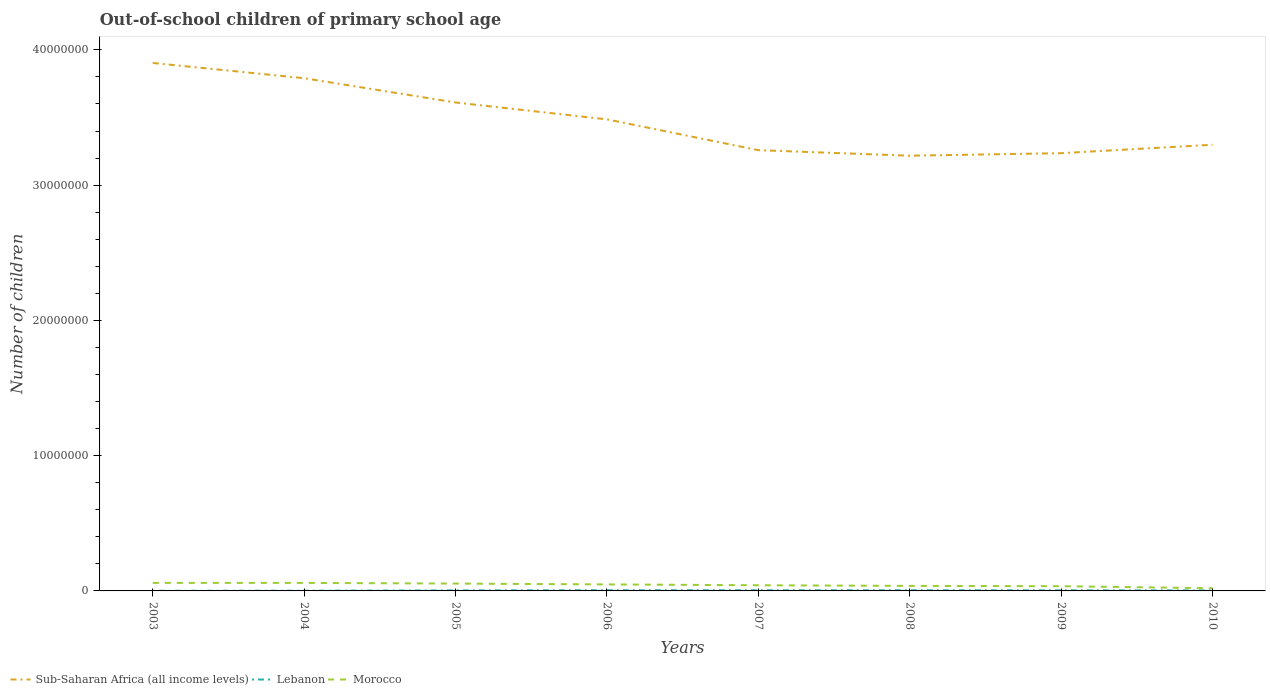How many different coloured lines are there?
Give a very brief answer. 3. Does the line corresponding to Lebanon intersect with the line corresponding to Morocco?
Provide a short and direct response. No. Across all years, what is the maximum number of out-of-school children in Sub-Saharan Africa (all income levels)?
Make the answer very short. 3.22e+07. In which year was the number of out-of-school children in Lebanon maximum?
Give a very brief answer. 2003. What is the total number of out-of-school children in Lebanon in the graph?
Make the answer very short. 1646. What is the difference between the highest and the second highest number of out-of-school children in Morocco?
Make the answer very short. 3.96e+05. Is the number of out-of-school children in Lebanon strictly greater than the number of out-of-school children in Sub-Saharan Africa (all income levels) over the years?
Your answer should be compact. Yes. How many lines are there?
Give a very brief answer. 3. How many years are there in the graph?
Offer a terse response. 8. What is the difference between two consecutive major ticks on the Y-axis?
Offer a very short reply. 1.00e+07. Are the values on the major ticks of Y-axis written in scientific E-notation?
Your answer should be compact. No. Does the graph contain any zero values?
Offer a terse response. No. Where does the legend appear in the graph?
Ensure brevity in your answer.  Bottom left. How are the legend labels stacked?
Offer a very short reply. Horizontal. What is the title of the graph?
Ensure brevity in your answer.  Out-of-school children of primary school age. Does "Costa Rica" appear as one of the legend labels in the graph?
Ensure brevity in your answer.  No. What is the label or title of the X-axis?
Offer a terse response. Years. What is the label or title of the Y-axis?
Your answer should be compact. Number of children. What is the Number of children in Sub-Saharan Africa (all income levels) in 2003?
Your answer should be very brief. 3.90e+07. What is the Number of children in Lebanon in 2003?
Your answer should be compact. 9541. What is the Number of children in Morocco in 2003?
Offer a terse response. 5.94e+05. What is the Number of children of Sub-Saharan Africa (all income levels) in 2004?
Keep it short and to the point. 3.79e+07. What is the Number of children of Lebanon in 2004?
Offer a very short reply. 1.70e+04. What is the Number of children in Morocco in 2004?
Give a very brief answer. 5.93e+05. What is the Number of children of Sub-Saharan Africa (all income levels) in 2005?
Your answer should be compact. 3.61e+07. What is the Number of children in Lebanon in 2005?
Offer a very short reply. 3.73e+04. What is the Number of children of Morocco in 2005?
Provide a succinct answer. 5.44e+05. What is the Number of children in Sub-Saharan Africa (all income levels) in 2006?
Your answer should be compact. 3.49e+07. What is the Number of children in Lebanon in 2006?
Your response must be concise. 5.22e+04. What is the Number of children in Morocco in 2006?
Ensure brevity in your answer.  4.81e+05. What is the Number of children in Sub-Saharan Africa (all income levels) in 2007?
Provide a short and direct response. 3.26e+07. What is the Number of children in Lebanon in 2007?
Provide a succinct answer. 4.99e+04. What is the Number of children in Morocco in 2007?
Give a very brief answer. 4.19e+05. What is the Number of children of Sub-Saharan Africa (all income levels) in 2008?
Provide a short and direct response. 3.22e+07. What is the Number of children of Lebanon in 2008?
Make the answer very short. 4.82e+04. What is the Number of children of Morocco in 2008?
Your answer should be compact. 3.71e+05. What is the Number of children in Sub-Saharan Africa (all income levels) in 2009?
Offer a very short reply. 3.24e+07. What is the Number of children of Lebanon in 2009?
Offer a terse response. 4.37e+04. What is the Number of children in Morocco in 2009?
Offer a very short reply. 3.49e+05. What is the Number of children of Sub-Saharan Africa (all income levels) in 2010?
Your response must be concise. 3.30e+07. What is the Number of children of Lebanon in 2010?
Keep it short and to the point. 3.49e+04. What is the Number of children in Morocco in 2010?
Your answer should be very brief. 1.98e+05. Across all years, what is the maximum Number of children in Sub-Saharan Africa (all income levels)?
Your answer should be compact. 3.90e+07. Across all years, what is the maximum Number of children of Lebanon?
Ensure brevity in your answer.  5.22e+04. Across all years, what is the maximum Number of children in Morocco?
Make the answer very short. 5.94e+05. Across all years, what is the minimum Number of children in Sub-Saharan Africa (all income levels)?
Ensure brevity in your answer.  3.22e+07. Across all years, what is the minimum Number of children of Lebanon?
Provide a succinct answer. 9541. Across all years, what is the minimum Number of children of Morocco?
Offer a terse response. 1.98e+05. What is the total Number of children in Sub-Saharan Africa (all income levels) in the graph?
Your answer should be compact. 2.78e+08. What is the total Number of children of Lebanon in the graph?
Your answer should be very brief. 2.93e+05. What is the total Number of children in Morocco in the graph?
Make the answer very short. 3.55e+06. What is the difference between the Number of children in Sub-Saharan Africa (all income levels) in 2003 and that in 2004?
Give a very brief answer. 1.13e+06. What is the difference between the Number of children of Lebanon in 2003 and that in 2004?
Ensure brevity in your answer.  -7426. What is the difference between the Number of children in Morocco in 2003 and that in 2004?
Keep it short and to the point. 761. What is the difference between the Number of children of Sub-Saharan Africa (all income levels) in 2003 and that in 2005?
Give a very brief answer. 2.92e+06. What is the difference between the Number of children in Lebanon in 2003 and that in 2005?
Provide a short and direct response. -2.78e+04. What is the difference between the Number of children in Morocco in 2003 and that in 2005?
Ensure brevity in your answer.  4.98e+04. What is the difference between the Number of children of Sub-Saharan Africa (all income levels) in 2003 and that in 2006?
Offer a very short reply. 4.17e+06. What is the difference between the Number of children of Lebanon in 2003 and that in 2006?
Keep it short and to the point. -4.26e+04. What is the difference between the Number of children in Morocco in 2003 and that in 2006?
Provide a short and direct response. 1.13e+05. What is the difference between the Number of children of Sub-Saharan Africa (all income levels) in 2003 and that in 2007?
Ensure brevity in your answer.  6.45e+06. What is the difference between the Number of children of Lebanon in 2003 and that in 2007?
Offer a very short reply. -4.03e+04. What is the difference between the Number of children in Morocco in 2003 and that in 2007?
Offer a terse response. 1.75e+05. What is the difference between the Number of children in Sub-Saharan Africa (all income levels) in 2003 and that in 2008?
Your answer should be very brief. 6.86e+06. What is the difference between the Number of children in Lebanon in 2003 and that in 2008?
Offer a very short reply. -3.87e+04. What is the difference between the Number of children of Morocco in 2003 and that in 2008?
Provide a short and direct response. 2.22e+05. What is the difference between the Number of children in Sub-Saharan Africa (all income levels) in 2003 and that in 2009?
Your response must be concise. 6.67e+06. What is the difference between the Number of children in Lebanon in 2003 and that in 2009?
Give a very brief answer. -3.42e+04. What is the difference between the Number of children in Morocco in 2003 and that in 2009?
Provide a succinct answer. 2.44e+05. What is the difference between the Number of children in Sub-Saharan Africa (all income levels) in 2003 and that in 2010?
Offer a very short reply. 6.05e+06. What is the difference between the Number of children in Lebanon in 2003 and that in 2010?
Provide a succinct answer. -2.54e+04. What is the difference between the Number of children of Morocco in 2003 and that in 2010?
Ensure brevity in your answer.  3.96e+05. What is the difference between the Number of children in Sub-Saharan Africa (all income levels) in 2004 and that in 2005?
Provide a succinct answer. 1.80e+06. What is the difference between the Number of children in Lebanon in 2004 and that in 2005?
Make the answer very short. -2.03e+04. What is the difference between the Number of children in Morocco in 2004 and that in 2005?
Offer a very short reply. 4.90e+04. What is the difference between the Number of children of Sub-Saharan Africa (all income levels) in 2004 and that in 2006?
Keep it short and to the point. 3.04e+06. What is the difference between the Number of children of Lebanon in 2004 and that in 2006?
Your answer should be compact. -3.52e+04. What is the difference between the Number of children of Morocco in 2004 and that in 2006?
Give a very brief answer. 1.12e+05. What is the difference between the Number of children of Sub-Saharan Africa (all income levels) in 2004 and that in 2007?
Give a very brief answer. 5.32e+06. What is the difference between the Number of children in Lebanon in 2004 and that in 2007?
Offer a very short reply. -3.29e+04. What is the difference between the Number of children of Morocco in 2004 and that in 2007?
Your response must be concise. 1.74e+05. What is the difference between the Number of children in Sub-Saharan Africa (all income levels) in 2004 and that in 2008?
Offer a very short reply. 5.73e+06. What is the difference between the Number of children of Lebanon in 2004 and that in 2008?
Your answer should be very brief. -3.12e+04. What is the difference between the Number of children of Morocco in 2004 and that in 2008?
Offer a very short reply. 2.21e+05. What is the difference between the Number of children in Sub-Saharan Africa (all income levels) in 2004 and that in 2009?
Offer a terse response. 5.54e+06. What is the difference between the Number of children in Lebanon in 2004 and that in 2009?
Keep it short and to the point. -2.68e+04. What is the difference between the Number of children in Morocco in 2004 and that in 2009?
Provide a succinct answer. 2.44e+05. What is the difference between the Number of children in Sub-Saharan Africa (all income levels) in 2004 and that in 2010?
Provide a succinct answer. 4.92e+06. What is the difference between the Number of children in Lebanon in 2004 and that in 2010?
Keep it short and to the point. -1.80e+04. What is the difference between the Number of children in Morocco in 2004 and that in 2010?
Provide a short and direct response. 3.95e+05. What is the difference between the Number of children of Sub-Saharan Africa (all income levels) in 2005 and that in 2006?
Ensure brevity in your answer.  1.25e+06. What is the difference between the Number of children of Lebanon in 2005 and that in 2006?
Provide a succinct answer. -1.49e+04. What is the difference between the Number of children of Morocco in 2005 and that in 2006?
Keep it short and to the point. 6.29e+04. What is the difference between the Number of children in Sub-Saharan Africa (all income levels) in 2005 and that in 2007?
Make the answer very short. 3.52e+06. What is the difference between the Number of children of Lebanon in 2005 and that in 2007?
Your answer should be compact. -1.26e+04. What is the difference between the Number of children in Morocco in 2005 and that in 2007?
Give a very brief answer. 1.25e+05. What is the difference between the Number of children in Sub-Saharan Africa (all income levels) in 2005 and that in 2008?
Your response must be concise. 3.93e+06. What is the difference between the Number of children of Lebanon in 2005 and that in 2008?
Your response must be concise. -1.09e+04. What is the difference between the Number of children of Morocco in 2005 and that in 2008?
Keep it short and to the point. 1.72e+05. What is the difference between the Number of children in Sub-Saharan Africa (all income levels) in 2005 and that in 2009?
Give a very brief answer. 3.75e+06. What is the difference between the Number of children of Lebanon in 2005 and that in 2009?
Provide a short and direct response. -6422. What is the difference between the Number of children of Morocco in 2005 and that in 2009?
Keep it short and to the point. 1.95e+05. What is the difference between the Number of children of Sub-Saharan Africa (all income levels) in 2005 and that in 2010?
Your response must be concise. 3.13e+06. What is the difference between the Number of children of Lebanon in 2005 and that in 2010?
Your answer should be compact. 2365. What is the difference between the Number of children of Morocco in 2005 and that in 2010?
Your answer should be compact. 3.46e+05. What is the difference between the Number of children of Sub-Saharan Africa (all income levels) in 2006 and that in 2007?
Your answer should be very brief. 2.28e+06. What is the difference between the Number of children in Lebanon in 2006 and that in 2007?
Provide a short and direct response. 2324. What is the difference between the Number of children of Morocco in 2006 and that in 2007?
Your answer should be very brief. 6.23e+04. What is the difference between the Number of children in Sub-Saharan Africa (all income levels) in 2006 and that in 2008?
Offer a terse response. 2.69e+06. What is the difference between the Number of children of Lebanon in 2006 and that in 2008?
Ensure brevity in your answer.  3970. What is the difference between the Number of children of Morocco in 2006 and that in 2008?
Make the answer very short. 1.10e+05. What is the difference between the Number of children in Sub-Saharan Africa (all income levels) in 2006 and that in 2009?
Your response must be concise. 2.50e+06. What is the difference between the Number of children of Lebanon in 2006 and that in 2009?
Your response must be concise. 8468. What is the difference between the Number of children in Morocco in 2006 and that in 2009?
Your answer should be compact. 1.32e+05. What is the difference between the Number of children of Sub-Saharan Africa (all income levels) in 2006 and that in 2010?
Your answer should be compact. 1.88e+06. What is the difference between the Number of children in Lebanon in 2006 and that in 2010?
Your answer should be very brief. 1.73e+04. What is the difference between the Number of children of Morocco in 2006 and that in 2010?
Your response must be concise. 2.83e+05. What is the difference between the Number of children in Sub-Saharan Africa (all income levels) in 2007 and that in 2008?
Your answer should be very brief. 4.10e+05. What is the difference between the Number of children in Lebanon in 2007 and that in 2008?
Keep it short and to the point. 1646. What is the difference between the Number of children in Morocco in 2007 and that in 2008?
Offer a terse response. 4.72e+04. What is the difference between the Number of children in Sub-Saharan Africa (all income levels) in 2007 and that in 2009?
Give a very brief answer. 2.23e+05. What is the difference between the Number of children in Lebanon in 2007 and that in 2009?
Offer a terse response. 6144. What is the difference between the Number of children of Morocco in 2007 and that in 2009?
Offer a very short reply. 6.94e+04. What is the difference between the Number of children of Sub-Saharan Africa (all income levels) in 2007 and that in 2010?
Make the answer very short. -3.99e+05. What is the difference between the Number of children in Lebanon in 2007 and that in 2010?
Your answer should be compact. 1.49e+04. What is the difference between the Number of children of Morocco in 2007 and that in 2010?
Your answer should be very brief. 2.21e+05. What is the difference between the Number of children in Sub-Saharan Africa (all income levels) in 2008 and that in 2009?
Make the answer very short. -1.87e+05. What is the difference between the Number of children of Lebanon in 2008 and that in 2009?
Your answer should be compact. 4498. What is the difference between the Number of children in Morocco in 2008 and that in 2009?
Your response must be concise. 2.22e+04. What is the difference between the Number of children of Sub-Saharan Africa (all income levels) in 2008 and that in 2010?
Your answer should be very brief. -8.09e+05. What is the difference between the Number of children of Lebanon in 2008 and that in 2010?
Your answer should be very brief. 1.33e+04. What is the difference between the Number of children of Morocco in 2008 and that in 2010?
Your answer should be compact. 1.74e+05. What is the difference between the Number of children of Sub-Saharan Africa (all income levels) in 2009 and that in 2010?
Provide a succinct answer. -6.22e+05. What is the difference between the Number of children of Lebanon in 2009 and that in 2010?
Provide a short and direct response. 8787. What is the difference between the Number of children in Morocco in 2009 and that in 2010?
Make the answer very short. 1.52e+05. What is the difference between the Number of children in Sub-Saharan Africa (all income levels) in 2003 and the Number of children in Lebanon in 2004?
Give a very brief answer. 3.90e+07. What is the difference between the Number of children of Sub-Saharan Africa (all income levels) in 2003 and the Number of children of Morocco in 2004?
Your answer should be very brief. 3.84e+07. What is the difference between the Number of children in Lebanon in 2003 and the Number of children in Morocco in 2004?
Make the answer very short. -5.83e+05. What is the difference between the Number of children in Sub-Saharan Africa (all income levels) in 2003 and the Number of children in Lebanon in 2005?
Offer a very short reply. 3.90e+07. What is the difference between the Number of children in Sub-Saharan Africa (all income levels) in 2003 and the Number of children in Morocco in 2005?
Offer a very short reply. 3.85e+07. What is the difference between the Number of children in Lebanon in 2003 and the Number of children in Morocco in 2005?
Your response must be concise. -5.34e+05. What is the difference between the Number of children in Sub-Saharan Africa (all income levels) in 2003 and the Number of children in Lebanon in 2006?
Provide a succinct answer. 3.90e+07. What is the difference between the Number of children of Sub-Saharan Africa (all income levels) in 2003 and the Number of children of Morocco in 2006?
Offer a very short reply. 3.86e+07. What is the difference between the Number of children in Lebanon in 2003 and the Number of children in Morocco in 2006?
Provide a succinct answer. -4.71e+05. What is the difference between the Number of children of Sub-Saharan Africa (all income levels) in 2003 and the Number of children of Lebanon in 2007?
Ensure brevity in your answer.  3.90e+07. What is the difference between the Number of children of Sub-Saharan Africa (all income levels) in 2003 and the Number of children of Morocco in 2007?
Make the answer very short. 3.86e+07. What is the difference between the Number of children in Lebanon in 2003 and the Number of children in Morocco in 2007?
Provide a succinct answer. -4.09e+05. What is the difference between the Number of children in Sub-Saharan Africa (all income levels) in 2003 and the Number of children in Lebanon in 2008?
Your answer should be very brief. 3.90e+07. What is the difference between the Number of children in Sub-Saharan Africa (all income levels) in 2003 and the Number of children in Morocco in 2008?
Keep it short and to the point. 3.87e+07. What is the difference between the Number of children in Lebanon in 2003 and the Number of children in Morocco in 2008?
Your answer should be very brief. -3.62e+05. What is the difference between the Number of children in Sub-Saharan Africa (all income levels) in 2003 and the Number of children in Lebanon in 2009?
Offer a terse response. 3.90e+07. What is the difference between the Number of children of Sub-Saharan Africa (all income levels) in 2003 and the Number of children of Morocco in 2009?
Offer a very short reply. 3.87e+07. What is the difference between the Number of children in Lebanon in 2003 and the Number of children in Morocco in 2009?
Give a very brief answer. -3.40e+05. What is the difference between the Number of children in Sub-Saharan Africa (all income levels) in 2003 and the Number of children in Lebanon in 2010?
Your answer should be very brief. 3.90e+07. What is the difference between the Number of children of Sub-Saharan Africa (all income levels) in 2003 and the Number of children of Morocco in 2010?
Offer a very short reply. 3.88e+07. What is the difference between the Number of children in Lebanon in 2003 and the Number of children in Morocco in 2010?
Keep it short and to the point. -1.88e+05. What is the difference between the Number of children in Sub-Saharan Africa (all income levels) in 2004 and the Number of children in Lebanon in 2005?
Your answer should be compact. 3.79e+07. What is the difference between the Number of children of Sub-Saharan Africa (all income levels) in 2004 and the Number of children of Morocco in 2005?
Offer a terse response. 3.74e+07. What is the difference between the Number of children of Lebanon in 2004 and the Number of children of Morocco in 2005?
Give a very brief answer. -5.27e+05. What is the difference between the Number of children in Sub-Saharan Africa (all income levels) in 2004 and the Number of children in Lebanon in 2006?
Provide a succinct answer. 3.79e+07. What is the difference between the Number of children in Sub-Saharan Africa (all income levels) in 2004 and the Number of children in Morocco in 2006?
Your answer should be compact. 3.74e+07. What is the difference between the Number of children in Lebanon in 2004 and the Number of children in Morocco in 2006?
Your answer should be compact. -4.64e+05. What is the difference between the Number of children in Sub-Saharan Africa (all income levels) in 2004 and the Number of children in Lebanon in 2007?
Provide a short and direct response. 3.79e+07. What is the difference between the Number of children in Sub-Saharan Africa (all income levels) in 2004 and the Number of children in Morocco in 2007?
Provide a short and direct response. 3.75e+07. What is the difference between the Number of children of Lebanon in 2004 and the Number of children of Morocco in 2007?
Give a very brief answer. -4.02e+05. What is the difference between the Number of children of Sub-Saharan Africa (all income levels) in 2004 and the Number of children of Lebanon in 2008?
Your answer should be very brief. 3.79e+07. What is the difference between the Number of children of Sub-Saharan Africa (all income levels) in 2004 and the Number of children of Morocco in 2008?
Give a very brief answer. 3.75e+07. What is the difference between the Number of children in Lebanon in 2004 and the Number of children in Morocco in 2008?
Provide a succinct answer. -3.54e+05. What is the difference between the Number of children of Sub-Saharan Africa (all income levels) in 2004 and the Number of children of Lebanon in 2009?
Provide a short and direct response. 3.79e+07. What is the difference between the Number of children in Sub-Saharan Africa (all income levels) in 2004 and the Number of children in Morocco in 2009?
Offer a terse response. 3.76e+07. What is the difference between the Number of children in Lebanon in 2004 and the Number of children in Morocco in 2009?
Keep it short and to the point. -3.32e+05. What is the difference between the Number of children in Sub-Saharan Africa (all income levels) in 2004 and the Number of children in Lebanon in 2010?
Ensure brevity in your answer.  3.79e+07. What is the difference between the Number of children of Sub-Saharan Africa (all income levels) in 2004 and the Number of children of Morocco in 2010?
Offer a very short reply. 3.77e+07. What is the difference between the Number of children in Lebanon in 2004 and the Number of children in Morocco in 2010?
Provide a succinct answer. -1.81e+05. What is the difference between the Number of children of Sub-Saharan Africa (all income levels) in 2005 and the Number of children of Lebanon in 2006?
Your answer should be compact. 3.61e+07. What is the difference between the Number of children in Sub-Saharan Africa (all income levels) in 2005 and the Number of children in Morocco in 2006?
Offer a very short reply. 3.56e+07. What is the difference between the Number of children of Lebanon in 2005 and the Number of children of Morocco in 2006?
Your response must be concise. -4.44e+05. What is the difference between the Number of children in Sub-Saharan Africa (all income levels) in 2005 and the Number of children in Lebanon in 2007?
Ensure brevity in your answer.  3.61e+07. What is the difference between the Number of children of Sub-Saharan Africa (all income levels) in 2005 and the Number of children of Morocco in 2007?
Provide a succinct answer. 3.57e+07. What is the difference between the Number of children of Lebanon in 2005 and the Number of children of Morocco in 2007?
Your response must be concise. -3.81e+05. What is the difference between the Number of children of Sub-Saharan Africa (all income levels) in 2005 and the Number of children of Lebanon in 2008?
Provide a short and direct response. 3.61e+07. What is the difference between the Number of children in Sub-Saharan Africa (all income levels) in 2005 and the Number of children in Morocco in 2008?
Provide a short and direct response. 3.57e+07. What is the difference between the Number of children of Lebanon in 2005 and the Number of children of Morocco in 2008?
Offer a terse response. -3.34e+05. What is the difference between the Number of children in Sub-Saharan Africa (all income levels) in 2005 and the Number of children in Lebanon in 2009?
Make the answer very short. 3.61e+07. What is the difference between the Number of children of Sub-Saharan Africa (all income levels) in 2005 and the Number of children of Morocco in 2009?
Make the answer very short. 3.58e+07. What is the difference between the Number of children in Lebanon in 2005 and the Number of children in Morocco in 2009?
Offer a very short reply. -3.12e+05. What is the difference between the Number of children in Sub-Saharan Africa (all income levels) in 2005 and the Number of children in Lebanon in 2010?
Give a very brief answer. 3.61e+07. What is the difference between the Number of children in Sub-Saharan Africa (all income levels) in 2005 and the Number of children in Morocco in 2010?
Offer a terse response. 3.59e+07. What is the difference between the Number of children of Lebanon in 2005 and the Number of children of Morocco in 2010?
Give a very brief answer. -1.60e+05. What is the difference between the Number of children in Sub-Saharan Africa (all income levels) in 2006 and the Number of children in Lebanon in 2007?
Keep it short and to the point. 3.48e+07. What is the difference between the Number of children of Sub-Saharan Africa (all income levels) in 2006 and the Number of children of Morocco in 2007?
Make the answer very short. 3.44e+07. What is the difference between the Number of children of Lebanon in 2006 and the Number of children of Morocco in 2007?
Your answer should be very brief. -3.66e+05. What is the difference between the Number of children of Sub-Saharan Africa (all income levels) in 2006 and the Number of children of Lebanon in 2008?
Offer a terse response. 3.48e+07. What is the difference between the Number of children of Sub-Saharan Africa (all income levels) in 2006 and the Number of children of Morocco in 2008?
Ensure brevity in your answer.  3.45e+07. What is the difference between the Number of children in Lebanon in 2006 and the Number of children in Morocco in 2008?
Offer a terse response. -3.19e+05. What is the difference between the Number of children of Sub-Saharan Africa (all income levels) in 2006 and the Number of children of Lebanon in 2009?
Offer a terse response. 3.48e+07. What is the difference between the Number of children of Sub-Saharan Africa (all income levels) in 2006 and the Number of children of Morocco in 2009?
Give a very brief answer. 3.45e+07. What is the difference between the Number of children of Lebanon in 2006 and the Number of children of Morocco in 2009?
Ensure brevity in your answer.  -2.97e+05. What is the difference between the Number of children in Sub-Saharan Africa (all income levels) in 2006 and the Number of children in Lebanon in 2010?
Your answer should be compact. 3.48e+07. What is the difference between the Number of children of Sub-Saharan Africa (all income levels) in 2006 and the Number of children of Morocco in 2010?
Ensure brevity in your answer.  3.47e+07. What is the difference between the Number of children in Lebanon in 2006 and the Number of children in Morocco in 2010?
Offer a terse response. -1.45e+05. What is the difference between the Number of children in Sub-Saharan Africa (all income levels) in 2007 and the Number of children in Lebanon in 2008?
Keep it short and to the point. 3.25e+07. What is the difference between the Number of children in Sub-Saharan Africa (all income levels) in 2007 and the Number of children in Morocco in 2008?
Offer a terse response. 3.22e+07. What is the difference between the Number of children of Lebanon in 2007 and the Number of children of Morocco in 2008?
Your answer should be compact. -3.22e+05. What is the difference between the Number of children in Sub-Saharan Africa (all income levels) in 2007 and the Number of children in Lebanon in 2009?
Your response must be concise. 3.25e+07. What is the difference between the Number of children in Sub-Saharan Africa (all income levels) in 2007 and the Number of children in Morocco in 2009?
Provide a short and direct response. 3.22e+07. What is the difference between the Number of children of Lebanon in 2007 and the Number of children of Morocco in 2009?
Provide a succinct answer. -2.99e+05. What is the difference between the Number of children of Sub-Saharan Africa (all income levels) in 2007 and the Number of children of Lebanon in 2010?
Keep it short and to the point. 3.26e+07. What is the difference between the Number of children of Sub-Saharan Africa (all income levels) in 2007 and the Number of children of Morocco in 2010?
Provide a short and direct response. 3.24e+07. What is the difference between the Number of children of Lebanon in 2007 and the Number of children of Morocco in 2010?
Keep it short and to the point. -1.48e+05. What is the difference between the Number of children of Sub-Saharan Africa (all income levels) in 2008 and the Number of children of Lebanon in 2009?
Offer a very short reply. 3.21e+07. What is the difference between the Number of children of Sub-Saharan Africa (all income levels) in 2008 and the Number of children of Morocco in 2009?
Make the answer very short. 3.18e+07. What is the difference between the Number of children in Lebanon in 2008 and the Number of children in Morocco in 2009?
Give a very brief answer. -3.01e+05. What is the difference between the Number of children of Sub-Saharan Africa (all income levels) in 2008 and the Number of children of Lebanon in 2010?
Offer a terse response. 3.21e+07. What is the difference between the Number of children of Sub-Saharan Africa (all income levels) in 2008 and the Number of children of Morocco in 2010?
Your answer should be compact. 3.20e+07. What is the difference between the Number of children in Lebanon in 2008 and the Number of children in Morocco in 2010?
Offer a very short reply. -1.49e+05. What is the difference between the Number of children in Sub-Saharan Africa (all income levels) in 2009 and the Number of children in Lebanon in 2010?
Your answer should be very brief. 3.23e+07. What is the difference between the Number of children in Sub-Saharan Africa (all income levels) in 2009 and the Number of children in Morocco in 2010?
Your response must be concise. 3.22e+07. What is the difference between the Number of children in Lebanon in 2009 and the Number of children in Morocco in 2010?
Keep it short and to the point. -1.54e+05. What is the average Number of children in Sub-Saharan Africa (all income levels) per year?
Provide a short and direct response. 3.48e+07. What is the average Number of children in Lebanon per year?
Make the answer very short. 3.66e+04. What is the average Number of children in Morocco per year?
Offer a very short reply. 4.44e+05. In the year 2003, what is the difference between the Number of children in Sub-Saharan Africa (all income levels) and Number of children in Lebanon?
Make the answer very short. 3.90e+07. In the year 2003, what is the difference between the Number of children in Sub-Saharan Africa (all income levels) and Number of children in Morocco?
Give a very brief answer. 3.84e+07. In the year 2003, what is the difference between the Number of children in Lebanon and Number of children in Morocco?
Provide a short and direct response. -5.84e+05. In the year 2004, what is the difference between the Number of children in Sub-Saharan Africa (all income levels) and Number of children in Lebanon?
Your answer should be compact. 3.79e+07. In the year 2004, what is the difference between the Number of children in Sub-Saharan Africa (all income levels) and Number of children in Morocco?
Provide a short and direct response. 3.73e+07. In the year 2004, what is the difference between the Number of children in Lebanon and Number of children in Morocco?
Give a very brief answer. -5.76e+05. In the year 2005, what is the difference between the Number of children of Sub-Saharan Africa (all income levels) and Number of children of Lebanon?
Offer a very short reply. 3.61e+07. In the year 2005, what is the difference between the Number of children in Sub-Saharan Africa (all income levels) and Number of children in Morocco?
Provide a succinct answer. 3.56e+07. In the year 2005, what is the difference between the Number of children of Lebanon and Number of children of Morocco?
Make the answer very short. -5.07e+05. In the year 2006, what is the difference between the Number of children in Sub-Saharan Africa (all income levels) and Number of children in Lebanon?
Ensure brevity in your answer.  3.48e+07. In the year 2006, what is the difference between the Number of children of Sub-Saharan Africa (all income levels) and Number of children of Morocco?
Give a very brief answer. 3.44e+07. In the year 2006, what is the difference between the Number of children of Lebanon and Number of children of Morocco?
Provide a succinct answer. -4.29e+05. In the year 2007, what is the difference between the Number of children of Sub-Saharan Africa (all income levels) and Number of children of Lebanon?
Ensure brevity in your answer.  3.25e+07. In the year 2007, what is the difference between the Number of children of Sub-Saharan Africa (all income levels) and Number of children of Morocco?
Ensure brevity in your answer.  3.22e+07. In the year 2007, what is the difference between the Number of children in Lebanon and Number of children in Morocco?
Offer a terse response. -3.69e+05. In the year 2008, what is the difference between the Number of children in Sub-Saharan Africa (all income levels) and Number of children in Lebanon?
Offer a terse response. 3.21e+07. In the year 2008, what is the difference between the Number of children of Sub-Saharan Africa (all income levels) and Number of children of Morocco?
Make the answer very short. 3.18e+07. In the year 2008, what is the difference between the Number of children of Lebanon and Number of children of Morocco?
Your answer should be compact. -3.23e+05. In the year 2009, what is the difference between the Number of children in Sub-Saharan Africa (all income levels) and Number of children in Lebanon?
Your response must be concise. 3.23e+07. In the year 2009, what is the difference between the Number of children of Sub-Saharan Africa (all income levels) and Number of children of Morocco?
Your answer should be compact. 3.20e+07. In the year 2009, what is the difference between the Number of children of Lebanon and Number of children of Morocco?
Make the answer very short. -3.06e+05. In the year 2010, what is the difference between the Number of children of Sub-Saharan Africa (all income levels) and Number of children of Lebanon?
Offer a very short reply. 3.29e+07. In the year 2010, what is the difference between the Number of children of Sub-Saharan Africa (all income levels) and Number of children of Morocco?
Your answer should be very brief. 3.28e+07. In the year 2010, what is the difference between the Number of children in Lebanon and Number of children in Morocco?
Your answer should be very brief. -1.63e+05. What is the ratio of the Number of children of Sub-Saharan Africa (all income levels) in 2003 to that in 2004?
Your answer should be compact. 1.03. What is the ratio of the Number of children of Lebanon in 2003 to that in 2004?
Provide a succinct answer. 0.56. What is the ratio of the Number of children in Sub-Saharan Africa (all income levels) in 2003 to that in 2005?
Offer a terse response. 1.08. What is the ratio of the Number of children in Lebanon in 2003 to that in 2005?
Provide a short and direct response. 0.26. What is the ratio of the Number of children of Morocco in 2003 to that in 2005?
Offer a very short reply. 1.09. What is the ratio of the Number of children in Sub-Saharan Africa (all income levels) in 2003 to that in 2006?
Ensure brevity in your answer.  1.12. What is the ratio of the Number of children of Lebanon in 2003 to that in 2006?
Your response must be concise. 0.18. What is the ratio of the Number of children of Morocco in 2003 to that in 2006?
Ensure brevity in your answer.  1.23. What is the ratio of the Number of children of Sub-Saharan Africa (all income levels) in 2003 to that in 2007?
Provide a succinct answer. 1.2. What is the ratio of the Number of children of Lebanon in 2003 to that in 2007?
Your response must be concise. 0.19. What is the ratio of the Number of children of Morocco in 2003 to that in 2007?
Provide a short and direct response. 1.42. What is the ratio of the Number of children in Sub-Saharan Africa (all income levels) in 2003 to that in 2008?
Keep it short and to the point. 1.21. What is the ratio of the Number of children in Lebanon in 2003 to that in 2008?
Provide a succinct answer. 0.2. What is the ratio of the Number of children of Morocco in 2003 to that in 2008?
Provide a succinct answer. 1.6. What is the ratio of the Number of children of Sub-Saharan Africa (all income levels) in 2003 to that in 2009?
Ensure brevity in your answer.  1.21. What is the ratio of the Number of children of Lebanon in 2003 to that in 2009?
Make the answer very short. 0.22. What is the ratio of the Number of children of Morocco in 2003 to that in 2009?
Give a very brief answer. 1.7. What is the ratio of the Number of children in Sub-Saharan Africa (all income levels) in 2003 to that in 2010?
Your response must be concise. 1.18. What is the ratio of the Number of children of Lebanon in 2003 to that in 2010?
Keep it short and to the point. 0.27. What is the ratio of the Number of children in Morocco in 2003 to that in 2010?
Your answer should be very brief. 3. What is the ratio of the Number of children in Sub-Saharan Africa (all income levels) in 2004 to that in 2005?
Your answer should be very brief. 1.05. What is the ratio of the Number of children of Lebanon in 2004 to that in 2005?
Provide a short and direct response. 0.45. What is the ratio of the Number of children of Morocco in 2004 to that in 2005?
Your response must be concise. 1.09. What is the ratio of the Number of children in Sub-Saharan Africa (all income levels) in 2004 to that in 2006?
Your response must be concise. 1.09. What is the ratio of the Number of children in Lebanon in 2004 to that in 2006?
Keep it short and to the point. 0.33. What is the ratio of the Number of children of Morocco in 2004 to that in 2006?
Make the answer very short. 1.23. What is the ratio of the Number of children in Sub-Saharan Africa (all income levels) in 2004 to that in 2007?
Your response must be concise. 1.16. What is the ratio of the Number of children of Lebanon in 2004 to that in 2007?
Provide a short and direct response. 0.34. What is the ratio of the Number of children in Morocco in 2004 to that in 2007?
Provide a succinct answer. 1.42. What is the ratio of the Number of children in Sub-Saharan Africa (all income levels) in 2004 to that in 2008?
Your response must be concise. 1.18. What is the ratio of the Number of children of Lebanon in 2004 to that in 2008?
Make the answer very short. 0.35. What is the ratio of the Number of children in Morocco in 2004 to that in 2008?
Provide a succinct answer. 1.6. What is the ratio of the Number of children in Sub-Saharan Africa (all income levels) in 2004 to that in 2009?
Offer a terse response. 1.17. What is the ratio of the Number of children of Lebanon in 2004 to that in 2009?
Keep it short and to the point. 0.39. What is the ratio of the Number of children in Morocco in 2004 to that in 2009?
Your response must be concise. 1.7. What is the ratio of the Number of children in Sub-Saharan Africa (all income levels) in 2004 to that in 2010?
Make the answer very short. 1.15. What is the ratio of the Number of children of Lebanon in 2004 to that in 2010?
Your response must be concise. 0.49. What is the ratio of the Number of children of Morocco in 2004 to that in 2010?
Ensure brevity in your answer.  3. What is the ratio of the Number of children in Sub-Saharan Africa (all income levels) in 2005 to that in 2006?
Make the answer very short. 1.04. What is the ratio of the Number of children in Lebanon in 2005 to that in 2006?
Your answer should be very brief. 0.71. What is the ratio of the Number of children of Morocco in 2005 to that in 2006?
Give a very brief answer. 1.13. What is the ratio of the Number of children of Sub-Saharan Africa (all income levels) in 2005 to that in 2007?
Keep it short and to the point. 1.11. What is the ratio of the Number of children in Lebanon in 2005 to that in 2007?
Your answer should be compact. 0.75. What is the ratio of the Number of children of Morocco in 2005 to that in 2007?
Offer a terse response. 1.3. What is the ratio of the Number of children of Sub-Saharan Africa (all income levels) in 2005 to that in 2008?
Provide a succinct answer. 1.12. What is the ratio of the Number of children in Lebanon in 2005 to that in 2008?
Give a very brief answer. 0.77. What is the ratio of the Number of children in Morocco in 2005 to that in 2008?
Offer a terse response. 1.46. What is the ratio of the Number of children of Sub-Saharan Africa (all income levels) in 2005 to that in 2009?
Your answer should be compact. 1.12. What is the ratio of the Number of children in Lebanon in 2005 to that in 2009?
Provide a short and direct response. 0.85. What is the ratio of the Number of children in Morocco in 2005 to that in 2009?
Provide a succinct answer. 1.56. What is the ratio of the Number of children of Sub-Saharan Africa (all income levels) in 2005 to that in 2010?
Your answer should be compact. 1.09. What is the ratio of the Number of children of Lebanon in 2005 to that in 2010?
Your response must be concise. 1.07. What is the ratio of the Number of children in Morocco in 2005 to that in 2010?
Your response must be concise. 2.75. What is the ratio of the Number of children in Sub-Saharan Africa (all income levels) in 2006 to that in 2007?
Offer a very short reply. 1.07. What is the ratio of the Number of children of Lebanon in 2006 to that in 2007?
Provide a succinct answer. 1.05. What is the ratio of the Number of children in Morocco in 2006 to that in 2007?
Offer a terse response. 1.15. What is the ratio of the Number of children in Sub-Saharan Africa (all income levels) in 2006 to that in 2008?
Provide a short and direct response. 1.08. What is the ratio of the Number of children of Lebanon in 2006 to that in 2008?
Your response must be concise. 1.08. What is the ratio of the Number of children in Morocco in 2006 to that in 2008?
Offer a very short reply. 1.29. What is the ratio of the Number of children in Sub-Saharan Africa (all income levels) in 2006 to that in 2009?
Your response must be concise. 1.08. What is the ratio of the Number of children in Lebanon in 2006 to that in 2009?
Provide a succinct answer. 1.19. What is the ratio of the Number of children in Morocco in 2006 to that in 2009?
Make the answer very short. 1.38. What is the ratio of the Number of children of Sub-Saharan Africa (all income levels) in 2006 to that in 2010?
Provide a short and direct response. 1.06. What is the ratio of the Number of children in Lebanon in 2006 to that in 2010?
Provide a short and direct response. 1.49. What is the ratio of the Number of children of Morocco in 2006 to that in 2010?
Provide a short and direct response. 2.43. What is the ratio of the Number of children of Sub-Saharan Africa (all income levels) in 2007 to that in 2008?
Your answer should be compact. 1.01. What is the ratio of the Number of children of Lebanon in 2007 to that in 2008?
Give a very brief answer. 1.03. What is the ratio of the Number of children in Morocco in 2007 to that in 2008?
Provide a short and direct response. 1.13. What is the ratio of the Number of children of Sub-Saharan Africa (all income levels) in 2007 to that in 2009?
Provide a succinct answer. 1.01. What is the ratio of the Number of children in Lebanon in 2007 to that in 2009?
Keep it short and to the point. 1.14. What is the ratio of the Number of children in Morocco in 2007 to that in 2009?
Your answer should be very brief. 1.2. What is the ratio of the Number of children of Sub-Saharan Africa (all income levels) in 2007 to that in 2010?
Your response must be concise. 0.99. What is the ratio of the Number of children of Lebanon in 2007 to that in 2010?
Offer a terse response. 1.43. What is the ratio of the Number of children of Morocco in 2007 to that in 2010?
Keep it short and to the point. 2.12. What is the ratio of the Number of children of Lebanon in 2008 to that in 2009?
Give a very brief answer. 1.1. What is the ratio of the Number of children in Morocco in 2008 to that in 2009?
Ensure brevity in your answer.  1.06. What is the ratio of the Number of children of Sub-Saharan Africa (all income levels) in 2008 to that in 2010?
Make the answer very short. 0.98. What is the ratio of the Number of children in Lebanon in 2008 to that in 2010?
Ensure brevity in your answer.  1.38. What is the ratio of the Number of children in Morocco in 2008 to that in 2010?
Your answer should be compact. 1.88. What is the ratio of the Number of children of Sub-Saharan Africa (all income levels) in 2009 to that in 2010?
Keep it short and to the point. 0.98. What is the ratio of the Number of children in Lebanon in 2009 to that in 2010?
Offer a very short reply. 1.25. What is the ratio of the Number of children of Morocco in 2009 to that in 2010?
Provide a succinct answer. 1.77. What is the difference between the highest and the second highest Number of children of Sub-Saharan Africa (all income levels)?
Give a very brief answer. 1.13e+06. What is the difference between the highest and the second highest Number of children of Lebanon?
Ensure brevity in your answer.  2324. What is the difference between the highest and the second highest Number of children of Morocco?
Offer a very short reply. 761. What is the difference between the highest and the lowest Number of children of Sub-Saharan Africa (all income levels)?
Provide a succinct answer. 6.86e+06. What is the difference between the highest and the lowest Number of children of Lebanon?
Your answer should be very brief. 4.26e+04. What is the difference between the highest and the lowest Number of children in Morocco?
Give a very brief answer. 3.96e+05. 